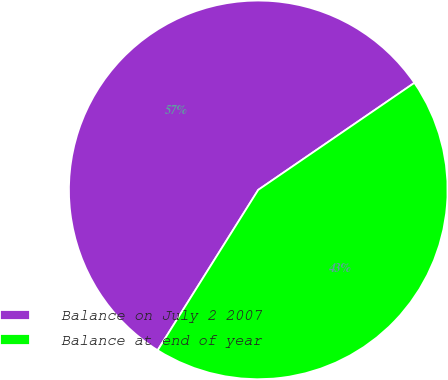Convert chart to OTSL. <chart><loc_0><loc_0><loc_500><loc_500><pie_chart><fcel>Balance on July 2 2007<fcel>Balance at end of year<nl><fcel>56.52%<fcel>43.48%<nl></chart> 